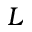<formula> <loc_0><loc_0><loc_500><loc_500>L</formula> 